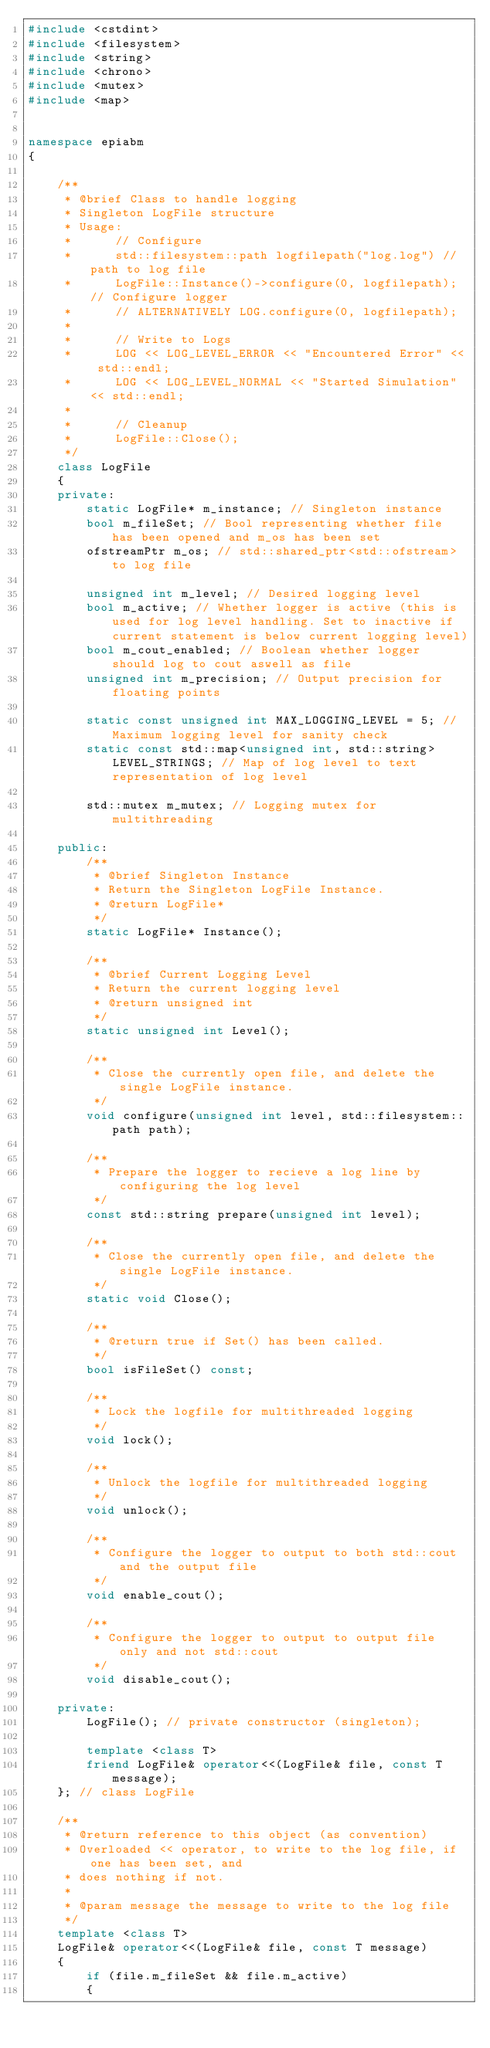Convert code to text. <code><loc_0><loc_0><loc_500><loc_500><_C++_>#include <cstdint>
#include <filesystem>
#include <string>
#include <chrono>
#include <mutex>
#include <map>


namespace epiabm
{

    /**
     * @brief Class to handle logging
     * Singleton LogFile structure
     * Usage:
     *      // Configure
     *      std::filesystem::path logfilepath("log.log") // path to log file
     *      LogFile::Instance()->configure(0, logfilepath); // Configure logger
     *      // ALTERNATIVELY LOG.configure(0, logfilepath);
     * 
     *      // Write to Logs
     *      LOG << LOG_LEVEL_ERROR << "Encountered Error" << std::endl;
     *      LOG << LOG_LEVEL_NORMAL << "Started Simulation" << std::endl;
     *      
     *      // Cleanup
     *      LogFile::Close();
     */
    class LogFile
    {
    private:
        static LogFile* m_instance; // Singleton instance
        bool m_fileSet; // Bool representing whether file has been opened and m_os has been set
        ofstreamPtr m_os; // std::shared_ptr<std::ofstream> to log file

        unsigned int m_level; // Desired logging level
        bool m_active; // Whether logger is active (this is used for log level handling. Set to inactive if current statement is below current logging level)
        bool m_cout_enabled; // Boolean whether logger should log to cout aswell as file
        unsigned int m_precision; // Output precision for floating points

        static const unsigned int MAX_LOGGING_LEVEL = 5; // Maximum logging level for sanity check
        static const std::map<unsigned int, std::string> LEVEL_STRINGS; // Map of log level to text representation of log level

        std::mutex m_mutex; // Logging mutex for multithreading

    public:
        /**
         * @brief Singleton Instance
         * Return the Singleton LogFile Instance.
         * @return LogFile*
         */
        static LogFile* Instance();

        /**
         * @brief Current Logging Level
         * Return the current logging level
         * @return unsigned int
         */
        static unsigned int Level();

        /**
         * Close the currently open file, and delete the single LogFile instance.
         */
        void configure(unsigned int level, std::filesystem::path path);

        /**
         * Prepare the logger to recieve a log line by configuring the log level
         */
        const std::string prepare(unsigned int level);

        /**
         * Close the currently open file, and delete the single LogFile instance.
         */
        static void Close();

        /**
         * @return true if Set() has been called.
         */
        bool isFileSet() const;

        /**
         * Lock the logfile for multithreaded logging
         */
        void lock();

        /**
         * Unlock the logfile for multithreaded logging
         */
        void unlock();

        /**
         * Configure the logger to output to both std::cout and the output file
         */
        void enable_cout();

        /**
         * Configure the logger to output to output file only and not std::cout
         */
        void disable_cout();

    private:
        LogFile(); // private constructor (singleton);

        template <class T>
        friend LogFile& operator<<(LogFile& file, const T message);
    }; // class LogFile

    /**
     * @return reference to this object (as convention)
     * Overloaded << operator, to write to the log file, if one has been set, and
     * does nothing if not.
     *
     * @param message the message to write to the log file
     */
    template <class T>
    LogFile& operator<<(LogFile& file, const T message)
    {
        if (file.m_fileSet && file.m_active)
        {</code> 